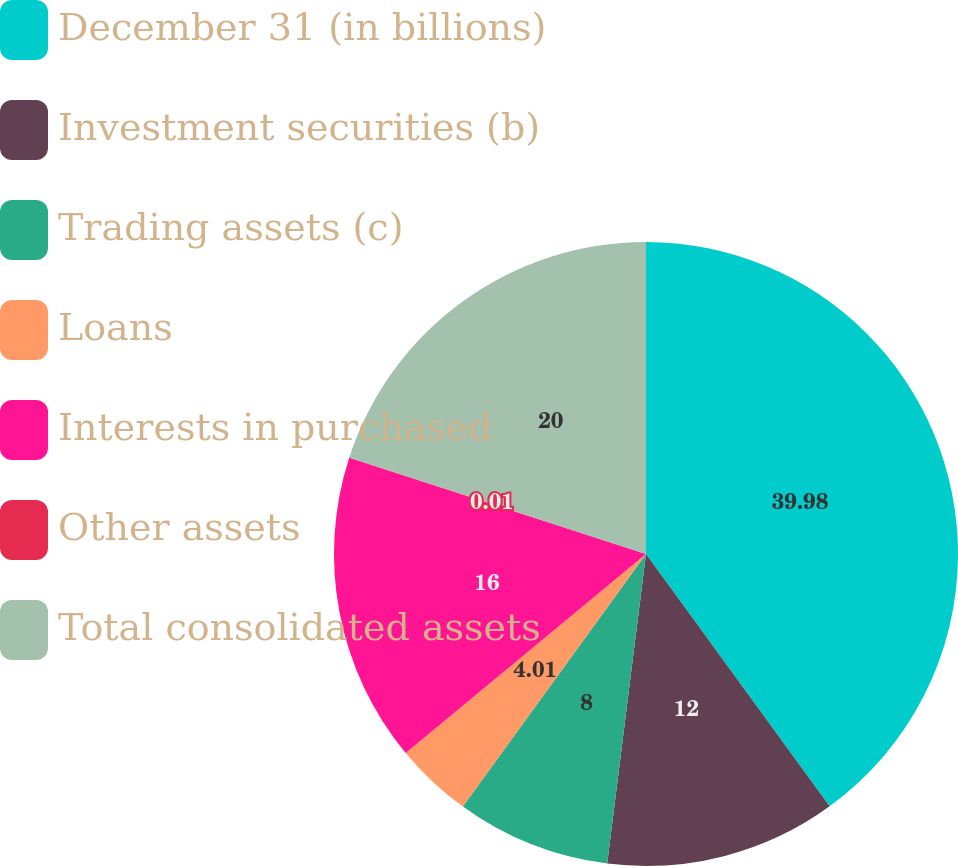<chart> <loc_0><loc_0><loc_500><loc_500><pie_chart><fcel>December 31 (in billions)<fcel>Investment securities (b)<fcel>Trading assets (c)<fcel>Loans<fcel>Interests in purchased<fcel>Other assets<fcel>Total consolidated assets<nl><fcel>39.99%<fcel>12.0%<fcel>8.0%<fcel>4.01%<fcel>16.0%<fcel>0.01%<fcel>20.0%<nl></chart> 